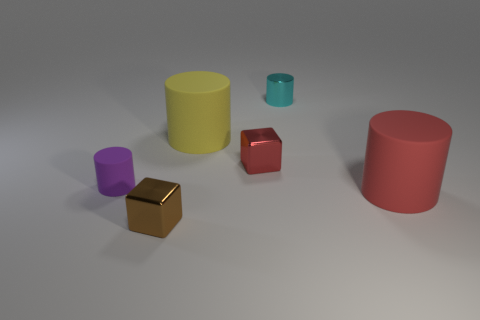Do the large cylinder behind the large red matte cylinder and the object behind the yellow thing have the same material?
Give a very brief answer. No. Is there anything else that has the same shape as the big red matte thing?
Your response must be concise. Yes. Are the purple cylinder and the tiny cylinder that is to the right of the tiny brown metallic cube made of the same material?
Keep it short and to the point. No. There is a cylinder that is in front of the tiny cylinder that is in front of the small cyan cylinder behind the brown block; what is its color?
Your response must be concise. Red. There is a matte object that is the same size as the brown block; what shape is it?
Your answer should be compact. Cylinder. Is there any other thing that is the same size as the purple rubber cylinder?
Your answer should be compact. Yes. Is the size of the metallic object behind the yellow matte thing the same as the metal block that is behind the purple rubber thing?
Your answer should be compact. Yes. There is a red object to the left of the metallic cylinder; what is its size?
Your response must be concise. Small. The other rubber object that is the same size as the yellow rubber object is what color?
Offer a very short reply. Red. Does the red rubber thing have the same size as the cyan thing?
Provide a succinct answer. No. 